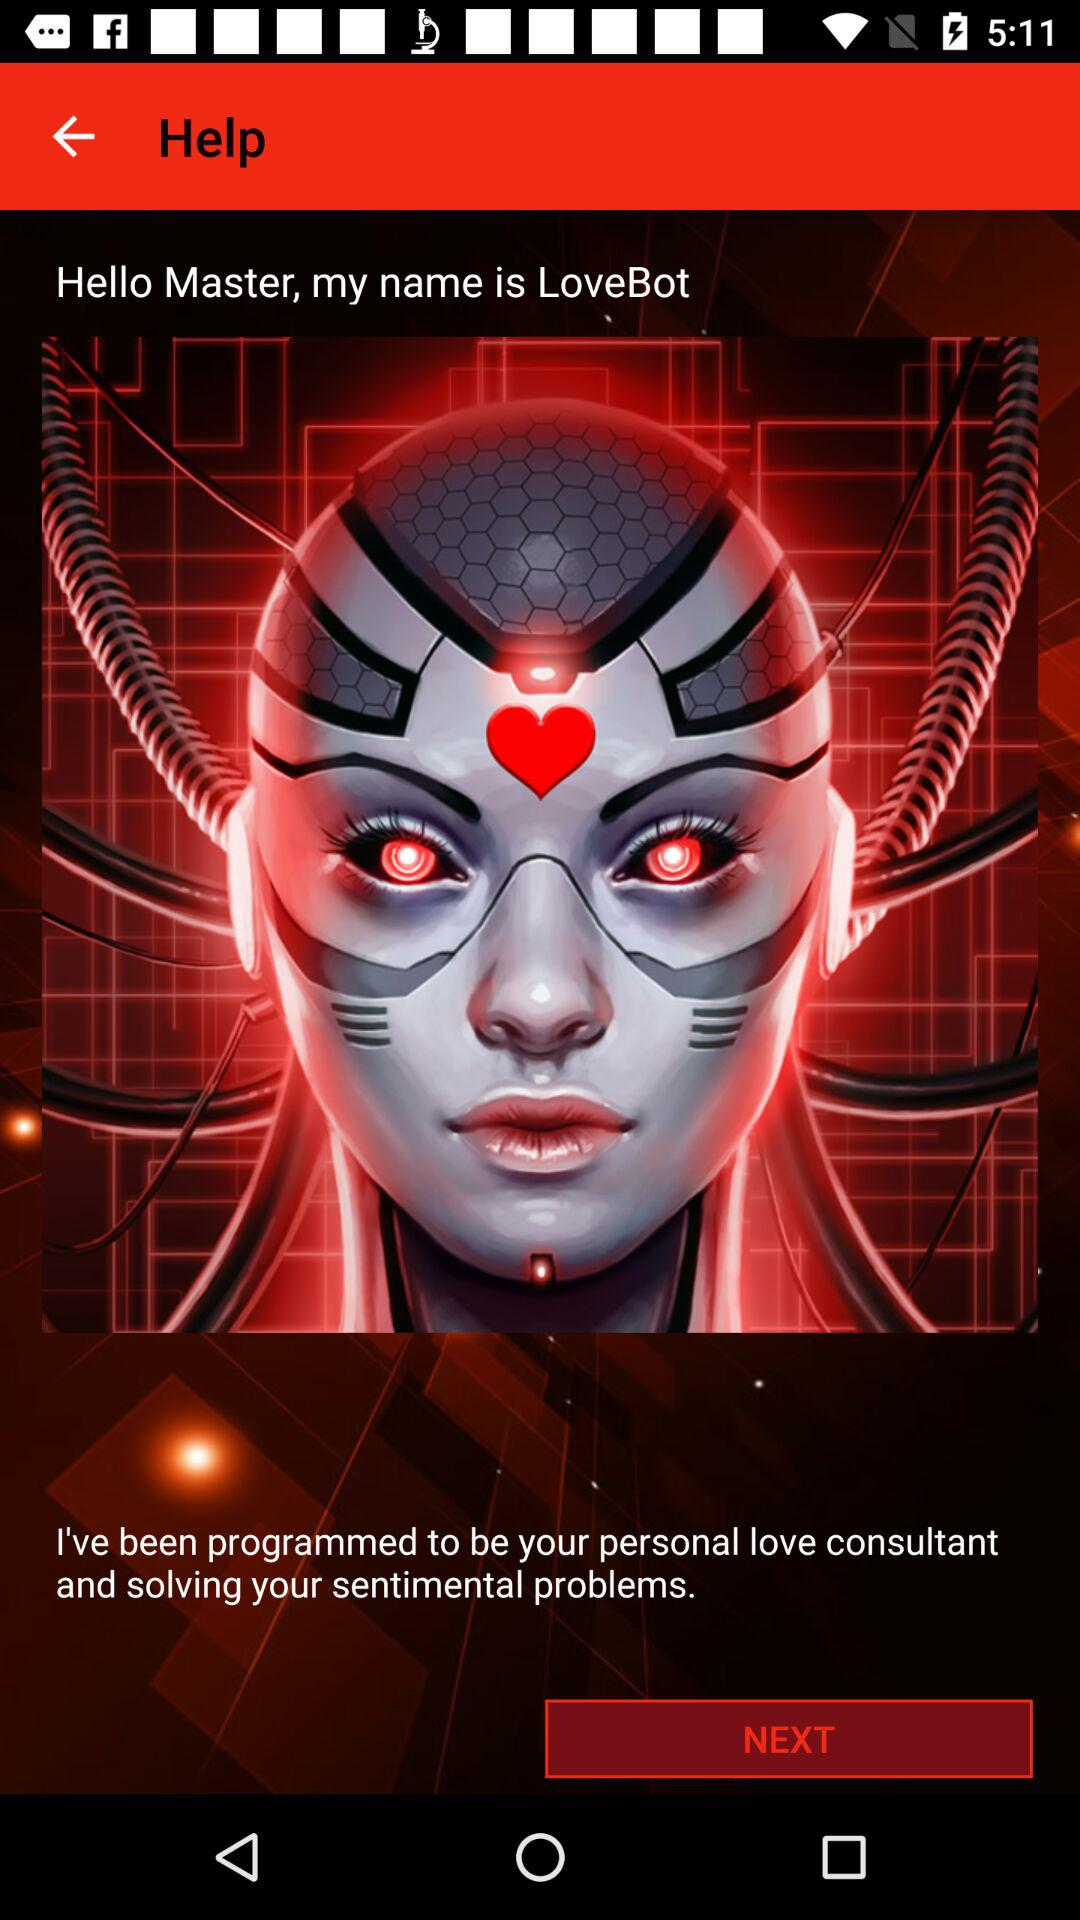Which version of "LoveBot" is this?
When the provided information is insufficient, respond with <no answer>. <no answer> 